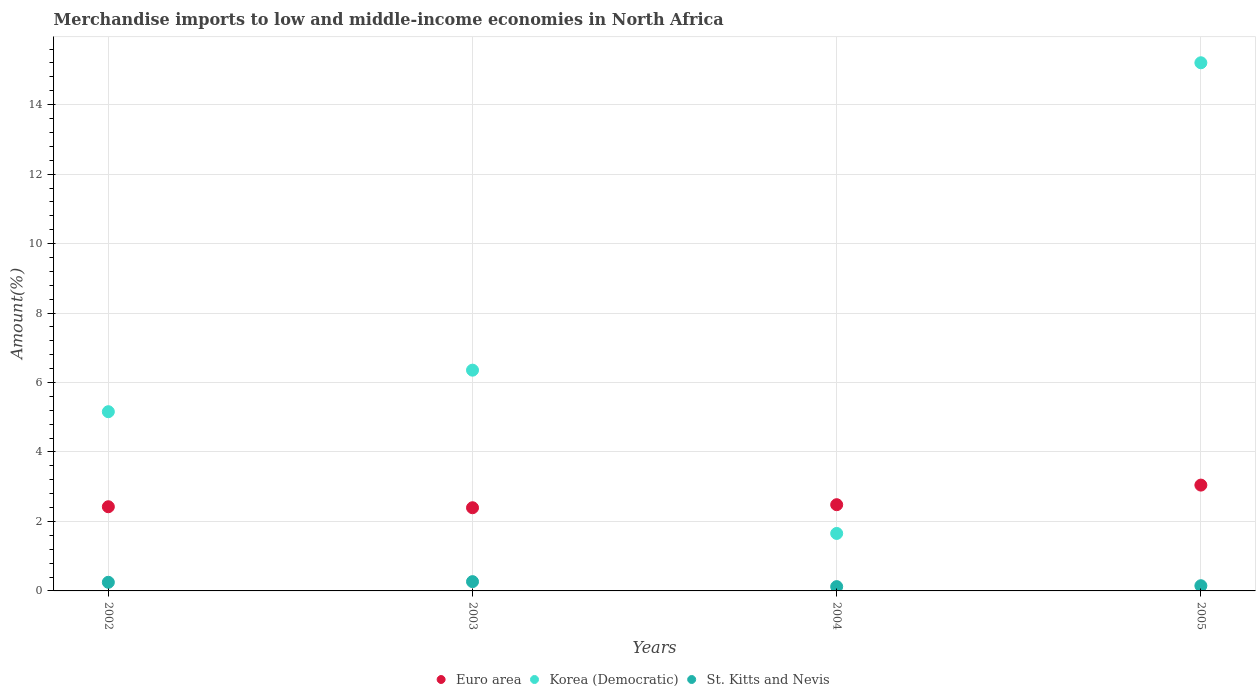What is the percentage of amount earned from merchandise imports in Euro area in 2004?
Give a very brief answer. 2.48. Across all years, what is the maximum percentage of amount earned from merchandise imports in St. Kitts and Nevis?
Provide a short and direct response. 0.27. Across all years, what is the minimum percentage of amount earned from merchandise imports in Euro area?
Your answer should be compact. 2.39. In which year was the percentage of amount earned from merchandise imports in Korea (Democratic) maximum?
Keep it short and to the point. 2005. In which year was the percentage of amount earned from merchandise imports in Euro area minimum?
Make the answer very short. 2003. What is the total percentage of amount earned from merchandise imports in Korea (Democratic) in the graph?
Your answer should be very brief. 28.38. What is the difference between the percentage of amount earned from merchandise imports in Korea (Democratic) in 2004 and that in 2005?
Offer a very short reply. -13.55. What is the difference between the percentage of amount earned from merchandise imports in Euro area in 2004 and the percentage of amount earned from merchandise imports in St. Kitts and Nevis in 2005?
Provide a short and direct response. 2.33. What is the average percentage of amount earned from merchandise imports in Euro area per year?
Provide a succinct answer. 2.59. In the year 2004, what is the difference between the percentage of amount earned from merchandise imports in Euro area and percentage of amount earned from merchandise imports in St. Kitts and Nevis?
Offer a terse response. 2.36. What is the ratio of the percentage of amount earned from merchandise imports in Korea (Democratic) in 2003 to that in 2004?
Keep it short and to the point. 3.84. Is the difference between the percentage of amount earned from merchandise imports in Euro area in 2002 and 2004 greater than the difference between the percentage of amount earned from merchandise imports in St. Kitts and Nevis in 2002 and 2004?
Your answer should be compact. No. What is the difference between the highest and the second highest percentage of amount earned from merchandise imports in Euro area?
Ensure brevity in your answer.  0.56. What is the difference between the highest and the lowest percentage of amount earned from merchandise imports in Euro area?
Provide a short and direct response. 0.65. Is the sum of the percentage of amount earned from merchandise imports in St. Kitts and Nevis in 2004 and 2005 greater than the maximum percentage of amount earned from merchandise imports in Korea (Democratic) across all years?
Offer a terse response. No. Does the percentage of amount earned from merchandise imports in Euro area monotonically increase over the years?
Offer a very short reply. No. Is the percentage of amount earned from merchandise imports in Korea (Democratic) strictly greater than the percentage of amount earned from merchandise imports in St. Kitts and Nevis over the years?
Give a very brief answer. Yes. Is the percentage of amount earned from merchandise imports in St. Kitts and Nevis strictly less than the percentage of amount earned from merchandise imports in Euro area over the years?
Ensure brevity in your answer.  Yes. How many dotlines are there?
Your response must be concise. 3. Where does the legend appear in the graph?
Provide a succinct answer. Bottom center. What is the title of the graph?
Provide a succinct answer. Merchandise imports to low and middle-income economies in North Africa. What is the label or title of the Y-axis?
Offer a very short reply. Amount(%). What is the Amount(%) in Euro area in 2002?
Keep it short and to the point. 2.42. What is the Amount(%) of Korea (Democratic) in 2002?
Offer a terse response. 5.16. What is the Amount(%) in St. Kitts and Nevis in 2002?
Offer a very short reply. 0.25. What is the Amount(%) in Euro area in 2003?
Keep it short and to the point. 2.39. What is the Amount(%) in Korea (Democratic) in 2003?
Give a very brief answer. 6.36. What is the Amount(%) of St. Kitts and Nevis in 2003?
Offer a terse response. 0.27. What is the Amount(%) in Euro area in 2004?
Your answer should be compact. 2.48. What is the Amount(%) of Korea (Democratic) in 2004?
Offer a terse response. 1.65. What is the Amount(%) in St. Kitts and Nevis in 2004?
Your answer should be compact. 0.12. What is the Amount(%) in Euro area in 2005?
Offer a very short reply. 3.05. What is the Amount(%) in Korea (Democratic) in 2005?
Your response must be concise. 15.21. What is the Amount(%) in St. Kitts and Nevis in 2005?
Provide a succinct answer. 0.15. Across all years, what is the maximum Amount(%) of Euro area?
Your answer should be very brief. 3.05. Across all years, what is the maximum Amount(%) in Korea (Democratic)?
Your response must be concise. 15.21. Across all years, what is the maximum Amount(%) in St. Kitts and Nevis?
Give a very brief answer. 0.27. Across all years, what is the minimum Amount(%) in Euro area?
Give a very brief answer. 2.39. Across all years, what is the minimum Amount(%) of Korea (Democratic)?
Offer a terse response. 1.65. Across all years, what is the minimum Amount(%) in St. Kitts and Nevis?
Offer a terse response. 0.12. What is the total Amount(%) in Euro area in the graph?
Give a very brief answer. 10.35. What is the total Amount(%) of Korea (Democratic) in the graph?
Your answer should be very brief. 28.38. What is the total Amount(%) of St. Kitts and Nevis in the graph?
Offer a very short reply. 0.79. What is the difference between the Amount(%) of Euro area in 2002 and that in 2003?
Give a very brief answer. 0.03. What is the difference between the Amount(%) in Korea (Democratic) in 2002 and that in 2003?
Offer a very short reply. -1.2. What is the difference between the Amount(%) in St. Kitts and Nevis in 2002 and that in 2003?
Offer a terse response. -0.02. What is the difference between the Amount(%) in Euro area in 2002 and that in 2004?
Your answer should be very brief. -0.06. What is the difference between the Amount(%) of Korea (Democratic) in 2002 and that in 2004?
Provide a short and direct response. 3.5. What is the difference between the Amount(%) in St. Kitts and Nevis in 2002 and that in 2004?
Give a very brief answer. 0.12. What is the difference between the Amount(%) of Euro area in 2002 and that in 2005?
Make the answer very short. -0.62. What is the difference between the Amount(%) in Korea (Democratic) in 2002 and that in 2005?
Your response must be concise. -10.05. What is the difference between the Amount(%) in St. Kitts and Nevis in 2002 and that in 2005?
Your response must be concise. 0.1. What is the difference between the Amount(%) of Euro area in 2003 and that in 2004?
Your response must be concise. -0.09. What is the difference between the Amount(%) of Korea (Democratic) in 2003 and that in 2004?
Offer a terse response. 4.7. What is the difference between the Amount(%) of St. Kitts and Nevis in 2003 and that in 2004?
Provide a short and direct response. 0.14. What is the difference between the Amount(%) of Euro area in 2003 and that in 2005?
Offer a very short reply. -0.65. What is the difference between the Amount(%) of Korea (Democratic) in 2003 and that in 2005?
Your answer should be compact. -8.85. What is the difference between the Amount(%) of St. Kitts and Nevis in 2003 and that in 2005?
Ensure brevity in your answer.  0.12. What is the difference between the Amount(%) in Euro area in 2004 and that in 2005?
Ensure brevity in your answer.  -0.56. What is the difference between the Amount(%) of Korea (Democratic) in 2004 and that in 2005?
Provide a short and direct response. -13.55. What is the difference between the Amount(%) of St. Kitts and Nevis in 2004 and that in 2005?
Your answer should be very brief. -0.03. What is the difference between the Amount(%) of Euro area in 2002 and the Amount(%) of Korea (Democratic) in 2003?
Your answer should be very brief. -3.93. What is the difference between the Amount(%) of Euro area in 2002 and the Amount(%) of St. Kitts and Nevis in 2003?
Keep it short and to the point. 2.16. What is the difference between the Amount(%) in Korea (Democratic) in 2002 and the Amount(%) in St. Kitts and Nevis in 2003?
Provide a succinct answer. 4.89. What is the difference between the Amount(%) of Euro area in 2002 and the Amount(%) of Korea (Democratic) in 2004?
Give a very brief answer. 0.77. What is the difference between the Amount(%) of Euro area in 2002 and the Amount(%) of St. Kitts and Nevis in 2004?
Provide a succinct answer. 2.3. What is the difference between the Amount(%) of Korea (Democratic) in 2002 and the Amount(%) of St. Kitts and Nevis in 2004?
Give a very brief answer. 5.04. What is the difference between the Amount(%) in Euro area in 2002 and the Amount(%) in Korea (Democratic) in 2005?
Your answer should be very brief. -12.78. What is the difference between the Amount(%) in Euro area in 2002 and the Amount(%) in St. Kitts and Nevis in 2005?
Your answer should be very brief. 2.27. What is the difference between the Amount(%) of Korea (Democratic) in 2002 and the Amount(%) of St. Kitts and Nevis in 2005?
Give a very brief answer. 5.01. What is the difference between the Amount(%) in Euro area in 2003 and the Amount(%) in Korea (Democratic) in 2004?
Provide a short and direct response. 0.74. What is the difference between the Amount(%) in Euro area in 2003 and the Amount(%) in St. Kitts and Nevis in 2004?
Your response must be concise. 2.27. What is the difference between the Amount(%) of Korea (Democratic) in 2003 and the Amount(%) of St. Kitts and Nevis in 2004?
Your answer should be very brief. 6.23. What is the difference between the Amount(%) in Euro area in 2003 and the Amount(%) in Korea (Democratic) in 2005?
Provide a short and direct response. -12.81. What is the difference between the Amount(%) of Euro area in 2003 and the Amount(%) of St. Kitts and Nevis in 2005?
Offer a very short reply. 2.25. What is the difference between the Amount(%) in Korea (Democratic) in 2003 and the Amount(%) in St. Kitts and Nevis in 2005?
Provide a succinct answer. 6.21. What is the difference between the Amount(%) of Euro area in 2004 and the Amount(%) of Korea (Democratic) in 2005?
Offer a very short reply. -12.72. What is the difference between the Amount(%) in Euro area in 2004 and the Amount(%) in St. Kitts and Nevis in 2005?
Keep it short and to the point. 2.33. What is the difference between the Amount(%) of Korea (Democratic) in 2004 and the Amount(%) of St. Kitts and Nevis in 2005?
Make the answer very short. 1.51. What is the average Amount(%) of Euro area per year?
Make the answer very short. 2.59. What is the average Amount(%) of Korea (Democratic) per year?
Make the answer very short. 7.09. What is the average Amount(%) in St. Kitts and Nevis per year?
Give a very brief answer. 0.2. In the year 2002, what is the difference between the Amount(%) in Euro area and Amount(%) in Korea (Democratic)?
Make the answer very short. -2.74. In the year 2002, what is the difference between the Amount(%) in Euro area and Amount(%) in St. Kitts and Nevis?
Provide a short and direct response. 2.18. In the year 2002, what is the difference between the Amount(%) in Korea (Democratic) and Amount(%) in St. Kitts and Nevis?
Make the answer very short. 4.91. In the year 2003, what is the difference between the Amount(%) of Euro area and Amount(%) of Korea (Democratic)?
Provide a succinct answer. -3.96. In the year 2003, what is the difference between the Amount(%) of Euro area and Amount(%) of St. Kitts and Nevis?
Your response must be concise. 2.13. In the year 2003, what is the difference between the Amount(%) of Korea (Democratic) and Amount(%) of St. Kitts and Nevis?
Your response must be concise. 6.09. In the year 2004, what is the difference between the Amount(%) in Euro area and Amount(%) in Korea (Democratic)?
Provide a short and direct response. 0.83. In the year 2004, what is the difference between the Amount(%) of Euro area and Amount(%) of St. Kitts and Nevis?
Provide a succinct answer. 2.36. In the year 2004, what is the difference between the Amount(%) in Korea (Democratic) and Amount(%) in St. Kitts and Nevis?
Ensure brevity in your answer.  1.53. In the year 2005, what is the difference between the Amount(%) of Euro area and Amount(%) of Korea (Democratic)?
Make the answer very short. -12.16. In the year 2005, what is the difference between the Amount(%) of Euro area and Amount(%) of St. Kitts and Nevis?
Provide a short and direct response. 2.9. In the year 2005, what is the difference between the Amount(%) of Korea (Democratic) and Amount(%) of St. Kitts and Nevis?
Offer a terse response. 15.06. What is the ratio of the Amount(%) of Euro area in 2002 to that in 2003?
Your response must be concise. 1.01. What is the ratio of the Amount(%) of Korea (Democratic) in 2002 to that in 2003?
Offer a very short reply. 0.81. What is the ratio of the Amount(%) of St. Kitts and Nevis in 2002 to that in 2003?
Your answer should be compact. 0.93. What is the ratio of the Amount(%) in Euro area in 2002 to that in 2004?
Make the answer very short. 0.98. What is the ratio of the Amount(%) in Korea (Democratic) in 2002 to that in 2004?
Your response must be concise. 3.12. What is the ratio of the Amount(%) in St. Kitts and Nevis in 2002 to that in 2004?
Make the answer very short. 2.01. What is the ratio of the Amount(%) in Euro area in 2002 to that in 2005?
Make the answer very short. 0.8. What is the ratio of the Amount(%) in Korea (Democratic) in 2002 to that in 2005?
Your response must be concise. 0.34. What is the ratio of the Amount(%) of St. Kitts and Nevis in 2002 to that in 2005?
Provide a short and direct response. 1.66. What is the ratio of the Amount(%) of Euro area in 2003 to that in 2004?
Offer a terse response. 0.96. What is the ratio of the Amount(%) of Korea (Democratic) in 2003 to that in 2004?
Provide a succinct answer. 3.84. What is the ratio of the Amount(%) in St. Kitts and Nevis in 2003 to that in 2004?
Ensure brevity in your answer.  2.16. What is the ratio of the Amount(%) in Euro area in 2003 to that in 2005?
Make the answer very short. 0.79. What is the ratio of the Amount(%) of Korea (Democratic) in 2003 to that in 2005?
Make the answer very short. 0.42. What is the ratio of the Amount(%) in St. Kitts and Nevis in 2003 to that in 2005?
Make the answer very short. 1.79. What is the ratio of the Amount(%) in Euro area in 2004 to that in 2005?
Offer a terse response. 0.81. What is the ratio of the Amount(%) in Korea (Democratic) in 2004 to that in 2005?
Your response must be concise. 0.11. What is the ratio of the Amount(%) in St. Kitts and Nevis in 2004 to that in 2005?
Offer a terse response. 0.83. What is the difference between the highest and the second highest Amount(%) of Euro area?
Your answer should be very brief. 0.56. What is the difference between the highest and the second highest Amount(%) in Korea (Democratic)?
Keep it short and to the point. 8.85. What is the difference between the highest and the second highest Amount(%) in St. Kitts and Nevis?
Keep it short and to the point. 0.02. What is the difference between the highest and the lowest Amount(%) of Euro area?
Your answer should be very brief. 0.65. What is the difference between the highest and the lowest Amount(%) in Korea (Democratic)?
Keep it short and to the point. 13.55. What is the difference between the highest and the lowest Amount(%) of St. Kitts and Nevis?
Offer a very short reply. 0.14. 